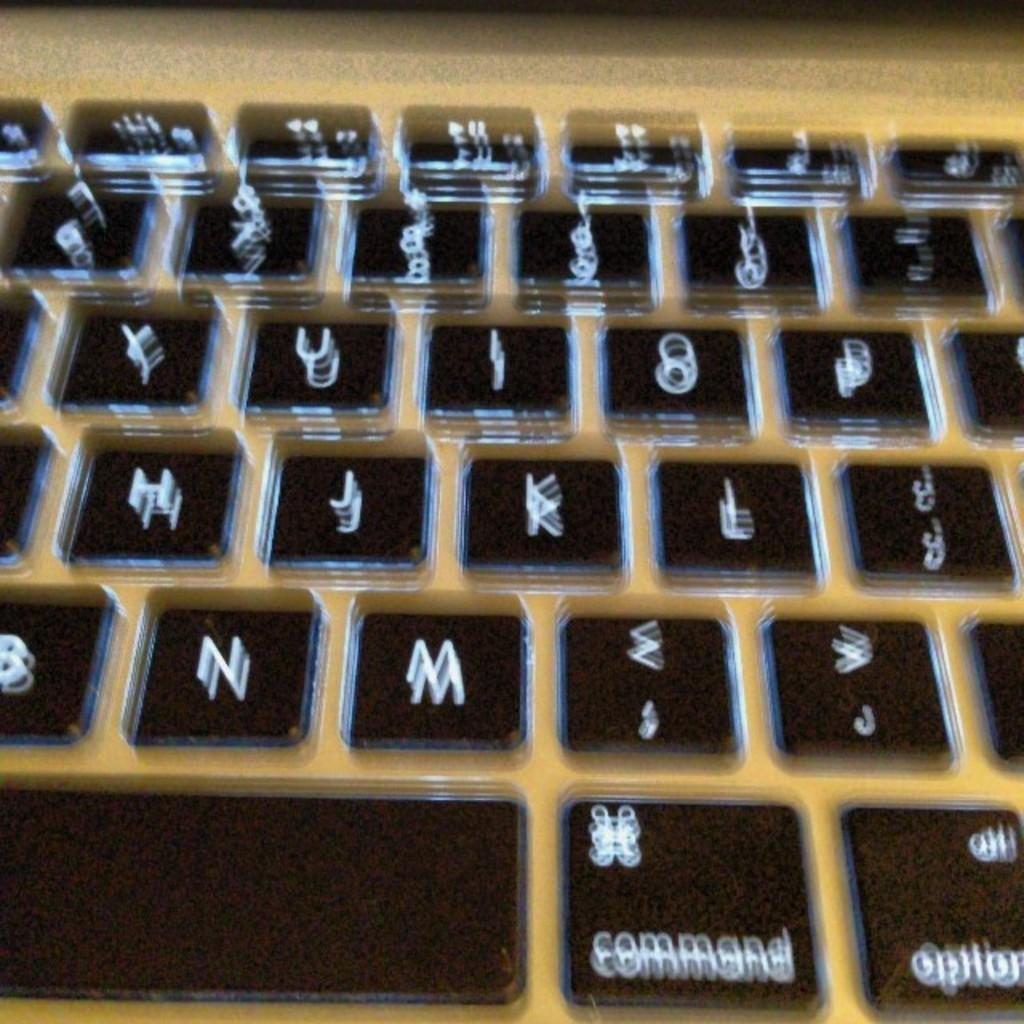What is the main object in the image? There is a keyboard in the image. What might the keyboard be used for? The keyboard is likely used for typing or inputting information. Can you describe the appearance of the keyboard? The image only shows a keyboard, so it is difficult to provide a detailed description of its appearance. What type of air can be seen coming out of the keyboard? There is no air visible in the image, as it only features a keyboard. 